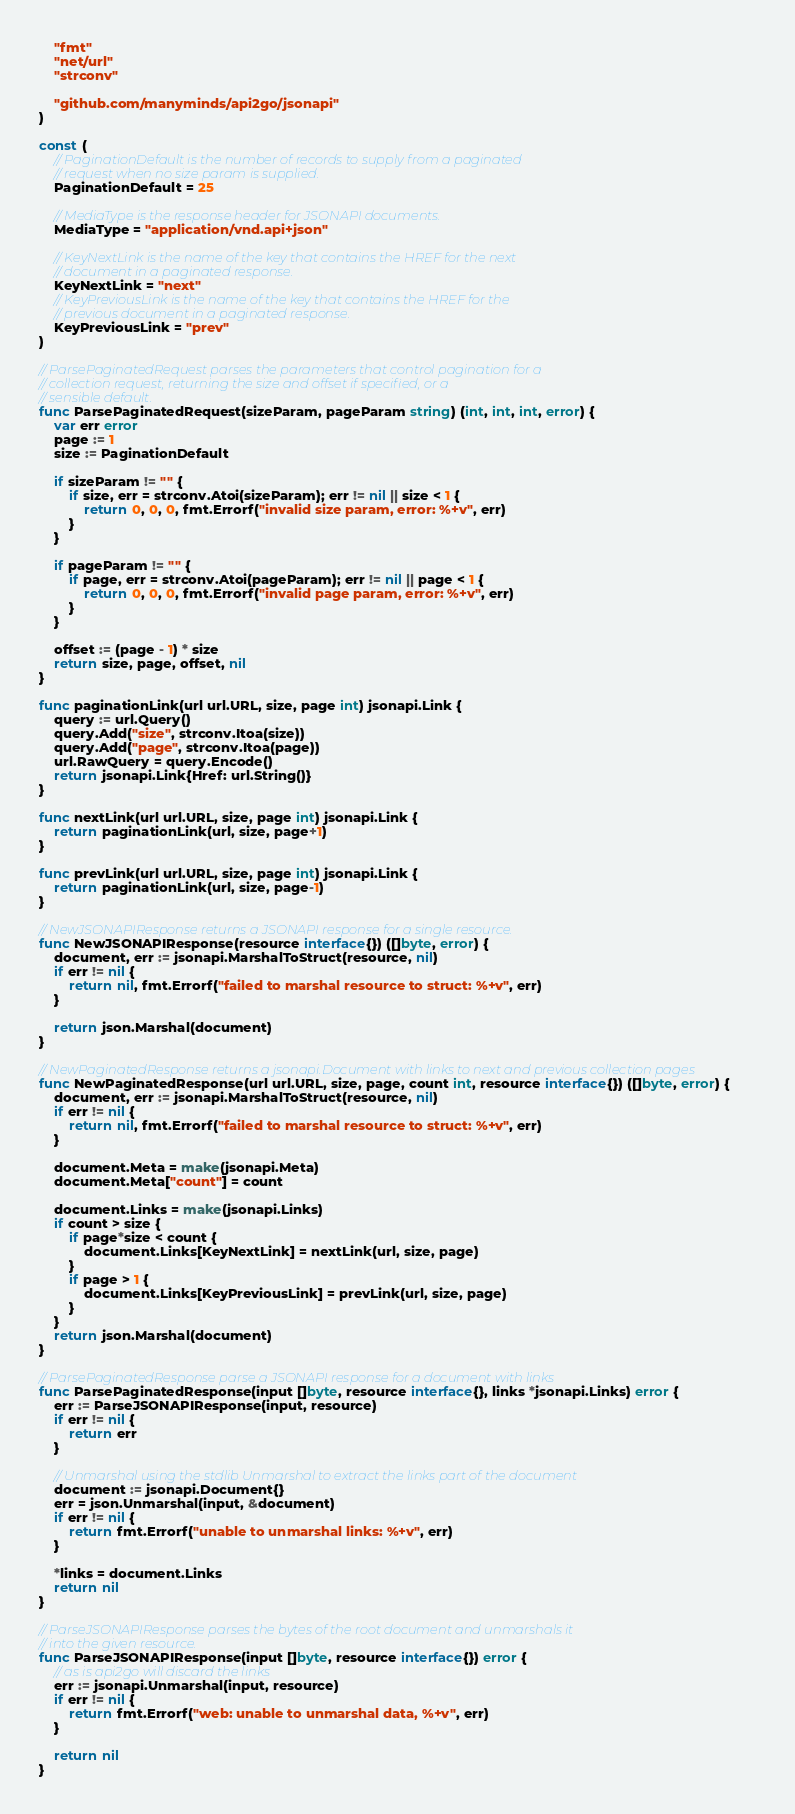<code> <loc_0><loc_0><loc_500><loc_500><_Go_>	"fmt"
	"net/url"
	"strconv"

	"github.com/manyminds/api2go/jsonapi"
)

const (
	// PaginationDefault is the number of records to supply from a paginated
	// request when no size param is supplied.
	PaginationDefault = 25

	// MediaType is the response header for JSONAPI documents.
	MediaType = "application/vnd.api+json"

	// KeyNextLink is the name of the key that contains the HREF for the next
	// document in a paginated response.
	KeyNextLink = "next"
	// KeyPreviousLink is the name of the key that contains the HREF for the
	// previous document in a paginated response.
	KeyPreviousLink = "prev"
)

// ParsePaginatedRequest parses the parameters that control pagination for a
// collection request, returning the size and offset if specified, or a
// sensible default.
func ParsePaginatedRequest(sizeParam, pageParam string) (int, int, int, error) {
	var err error
	page := 1
	size := PaginationDefault

	if sizeParam != "" {
		if size, err = strconv.Atoi(sizeParam); err != nil || size < 1 {
			return 0, 0, 0, fmt.Errorf("invalid size param, error: %+v", err)
		}
	}

	if pageParam != "" {
		if page, err = strconv.Atoi(pageParam); err != nil || page < 1 {
			return 0, 0, 0, fmt.Errorf("invalid page param, error: %+v", err)
		}
	}

	offset := (page - 1) * size
	return size, page, offset, nil
}

func paginationLink(url url.URL, size, page int) jsonapi.Link {
	query := url.Query()
	query.Add("size", strconv.Itoa(size))
	query.Add("page", strconv.Itoa(page))
	url.RawQuery = query.Encode()
	return jsonapi.Link{Href: url.String()}
}

func nextLink(url url.URL, size, page int) jsonapi.Link {
	return paginationLink(url, size, page+1)
}

func prevLink(url url.URL, size, page int) jsonapi.Link {
	return paginationLink(url, size, page-1)
}

// NewJSONAPIResponse returns a JSONAPI response for a single resource.
func NewJSONAPIResponse(resource interface{}) ([]byte, error) {
	document, err := jsonapi.MarshalToStruct(resource, nil)
	if err != nil {
		return nil, fmt.Errorf("failed to marshal resource to struct: %+v", err)
	}

	return json.Marshal(document)
}

// NewPaginatedResponse returns a jsonapi.Document with links to next and previous collection pages
func NewPaginatedResponse(url url.URL, size, page, count int, resource interface{}) ([]byte, error) {
	document, err := jsonapi.MarshalToStruct(resource, nil)
	if err != nil {
		return nil, fmt.Errorf("failed to marshal resource to struct: %+v", err)
	}

	document.Meta = make(jsonapi.Meta)
	document.Meta["count"] = count

	document.Links = make(jsonapi.Links)
	if count > size {
		if page*size < count {
			document.Links[KeyNextLink] = nextLink(url, size, page)
		}
		if page > 1 {
			document.Links[KeyPreviousLink] = prevLink(url, size, page)
		}
	}
	return json.Marshal(document)
}

// ParsePaginatedResponse parse a JSONAPI response for a document with links
func ParsePaginatedResponse(input []byte, resource interface{}, links *jsonapi.Links) error {
	err := ParseJSONAPIResponse(input, resource)
	if err != nil {
		return err
	}

	// Unmarshal using the stdlib Unmarshal to extract the links part of the document
	document := jsonapi.Document{}
	err = json.Unmarshal(input, &document)
	if err != nil {
		return fmt.Errorf("unable to unmarshal links: %+v", err)
	}

	*links = document.Links
	return nil
}

// ParseJSONAPIResponse parses the bytes of the root document and unmarshals it
// into the given resource.
func ParseJSONAPIResponse(input []byte, resource interface{}) error {
	// as is api2go will discard the links
	err := jsonapi.Unmarshal(input, resource)
	if err != nil {
		return fmt.Errorf("web: unable to unmarshal data, %+v", err)
	}

	return nil
}
</code> 